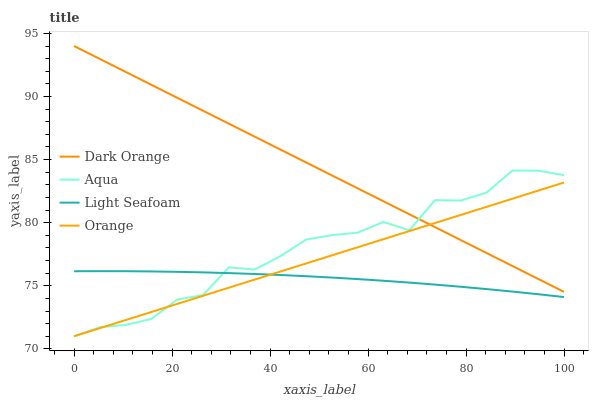Does Dark Orange have the minimum area under the curve?
Answer yes or no. No. Does Light Seafoam have the maximum area under the curve?
Answer yes or no. No. Is Dark Orange the smoothest?
Answer yes or no. No. Is Dark Orange the roughest?
Answer yes or no. No. Does Light Seafoam have the lowest value?
Answer yes or no. No. Does Light Seafoam have the highest value?
Answer yes or no. No. Is Light Seafoam less than Dark Orange?
Answer yes or no. Yes. Is Dark Orange greater than Light Seafoam?
Answer yes or no. Yes. Does Light Seafoam intersect Dark Orange?
Answer yes or no. No. 